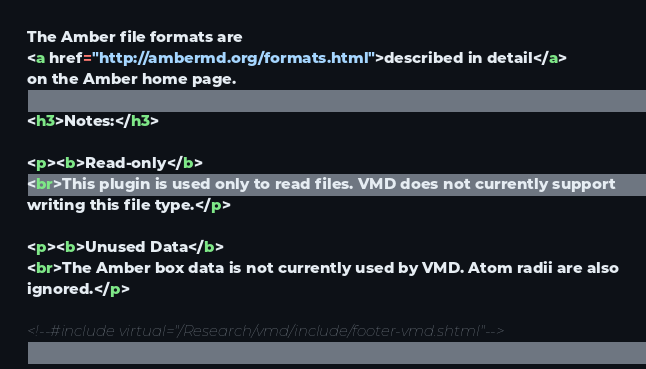Convert code to text. <code><loc_0><loc_0><loc_500><loc_500><_HTML_>The Amber file formats are 
<a href="http://ambermd.org/formats.html">described in detail</a>
on the Amber home page.

<h3>Notes:</h3>

<p><b>Read-only</b>
<br>This plugin is used only to read files. VMD does not currently support
writing this file type.</p>

<p><b>Unused Data</b>
<br>The Amber box data is not currently used by VMD. Atom radii are also
ignored.</p>

<!--#include virtual="/Research/vmd/include/footer-vmd.shtml"-->

</code> 